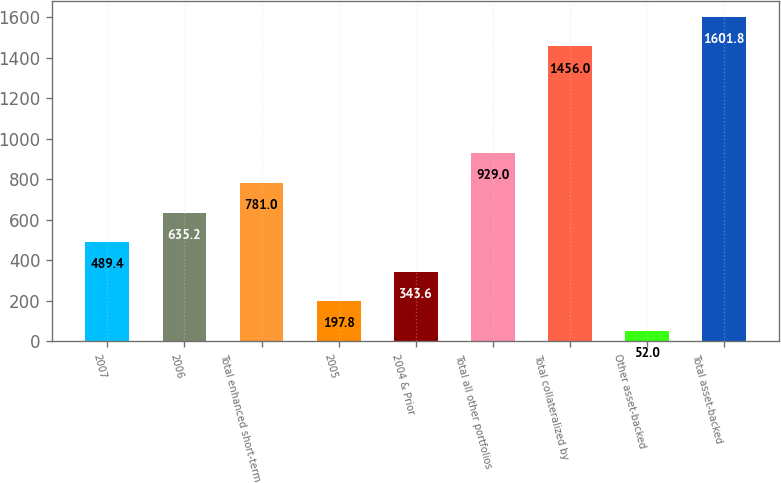<chart> <loc_0><loc_0><loc_500><loc_500><bar_chart><fcel>2007<fcel>2006<fcel>Total enhanced short-term<fcel>2005<fcel>2004 & Prior<fcel>Total all other portfolios<fcel>Total collateralized by<fcel>Other asset-backed<fcel>Total asset-backed<nl><fcel>489.4<fcel>635.2<fcel>781<fcel>197.8<fcel>343.6<fcel>929<fcel>1456<fcel>52<fcel>1601.8<nl></chart> 